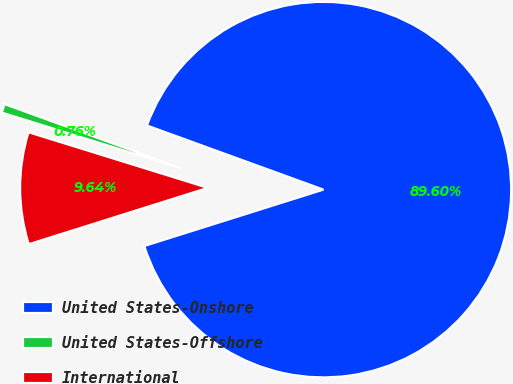Convert chart to OTSL. <chart><loc_0><loc_0><loc_500><loc_500><pie_chart><fcel>United States-Onshore<fcel>United States-Offshore<fcel>International<nl><fcel>89.6%<fcel>0.76%<fcel>9.64%<nl></chart> 